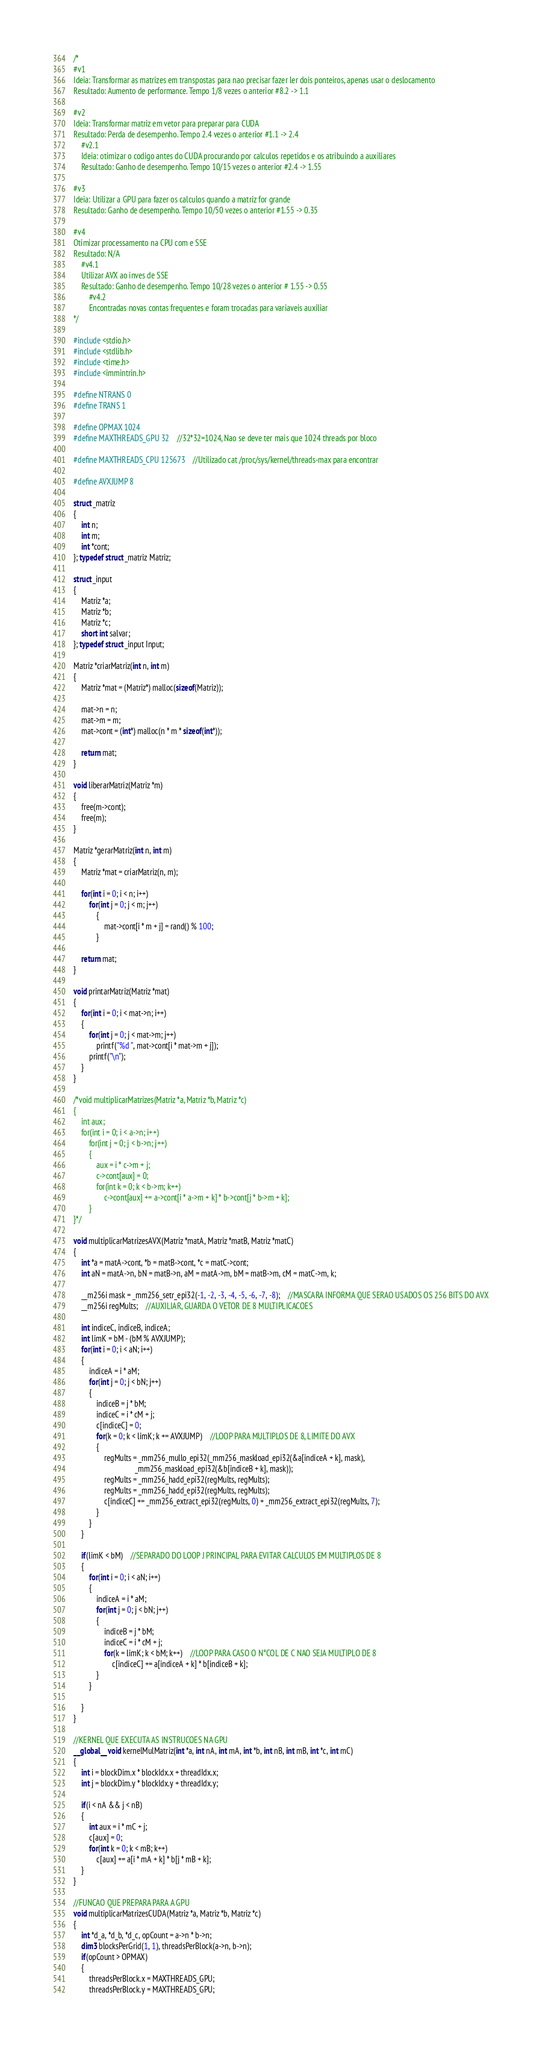<code> <loc_0><loc_0><loc_500><loc_500><_Cuda_>/*
#v1
Ideia: Transformar as matrizes em transpostas para nao precisar fazer ler dois ponteiros, apenas usar o deslocamento
Resultado: Aumento de performance. Tempo 1/8 vezes o anterior #8.2 -> 1.1

#v2
Ideia: Transformar matriz em vetor para preparar para CUDA
Resultado: Perda de desempenho. Tempo 2.4 vezes o anterior #1.1 -> 2.4
	#v2.1
	Ideia: otimizar o codigo antes do CUDA procurando por calculos repetidos e os atribuindo a auxiliares
	Resultado: Ganho de desempenho. Tempo 10/15 vezes o anterior #2.4 -> 1.55

#v3
Ideia: Utilizar a GPU para fazer os calculos quando a matriz for grande
Resultado: Ganho de desempenho. Tempo 10/50 vezes o anterior #1.55 -> 0.35

#v4
Otimizar processamento na CPU com e SSE
Resultado: N/A
	#v4.1
	Utilizar AVX ao inves de SSE
	Resultado: Ganho de desempenho. Tempo 10/28 vezes o anterior # 1.55 -> 0.55
		#v4.2
		Encontradas novas contas frequentes e foram trocadas para variaveis auxiliar
*/

#include <stdio.h>
#include <stdlib.h>
#include <time.h>
#include <immintrin.h>

#define NTRANS 0
#define TRANS 1

#define OPMAX 1024
#define MAXTHREADS_GPU 32	//32*32=1024, Nao se deve ter mais que 1024 threads por bloco

#define MAXTHREADS_CPU 125673	//Utilizado cat /proc/sys/kernel/threads-max para encontrar

#define AVXJUMP 8

struct _matriz
{
	int n;
	int m;
	int *cont;
}; typedef struct _matriz Matriz;

struct _input
{
	Matriz *a;
	Matriz *b;
	Matriz *c;
	short int salvar;
}; typedef struct _input Input;

Matriz *criarMatriz(int n, int m)
{
	Matriz *mat = (Matriz*) malloc(sizeof(Matriz));

	mat->n = n;
	mat->m = m;
	mat->cont = (int*) malloc(n * m * sizeof(int*));

	return mat;
}

void liberarMatriz(Matriz *m)
{
	free(m->cont);
	free(m);
}

Matriz *gerarMatriz(int n, int m)
{
	Matriz *mat = criarMatriz(n, m);
	
	for(int i = 0; i < n; i++)
		for(int j = 0; j < m; j++)
			{
				mat->cont[i * m + j] = rand() % 100;
			}

	return mat;
}

void printarMatriz(Matriz *mat)
{
	for(int i = 0; i < mat->n; i++)
	{
		for(int j = 0; j < mat->m; j++)
			printf("%d ", mat->cont[i * mat->m + j]);
		printf("\n");
	}
}

/*void multiplicarMatrizes(Matriz *a, Matriz *b, Matriz *c)
{
	int aux;
	for(int i = 0; i < a->n; i++)
		for(int j = 0; j < b->n; j++)
		{
			aux = i * c->m + j;
			c->cont[aux] = 0;
			for(int k = 0; k < b->m; k++)
				c->cont[aux] += a->cont[i * a->m + k] * b->cont[j * b->m + k];
		}
}*/

void multiplicarMatrizesAVX(Matriz *matA, Matriz *matB, Matriz *matC)
{
	int *a = matA->cont, *b = matB->cont, *c = matC->cont;
	int aN = matA->n, bN = matB->n, aM = matA->m, bM = matB->m, cM = matC->m, k;

	__m256i mask = _mm256_setr_epi32(-1, -2, -3, -4, -5, -6, -7, -8);	//MASCARA INFORMA QUE SERAO USADOS OS 256 BITS DO AVX
	__m256i regMults;	//AUXILIAR, GUARDA O VETOR DE 8 MULTIPLICACOES

	int indiceC, indiceB, indiceA;
	int limK = bM - (bM % AVXJUMP);
	for(int i = 0; i < aN; i++)
	{
		indiceA = i * aM;
		for(int j = 0; j < bN; j++)
		{
			indiceB = j * bM;
			indiceC = i * cM + j;
			c[indiceC] = 0;
			for(k = 0; k < limK; k += AVXJUMP)	//LOOP PARA MULTIPLOS DE 8, LIMITE DO AVX
			{
				regMults = _mm256_mullo_epi32(_mm256_maskload_epi32(&a[indiceA + k], mask),
								_mm256_maskload_epi32(&b[indiceB + k], mask));
				regMults = _mm256_hadd_epi32(regMults, regMults);
				regMults = _mm256_hadd_epi32(regMults, regMults);
				c[indiceC] += _mm256_extract_epi32(regMults, 0) + _mm256_extract_epi32(regMults, 7);
			}
		}
	}

	if(limK < bM)	//SEPARADO DO LOOP J PRINCIPAL PARA EVITAR CALCULOS EM MULTIPLOS DE 8
	{
		for(int i = 0; i < aN; i++)
		{
			indiceA = i * aM;
			for(int j = 0; j < bN; j++)
			{
				indiceB = j * bM;
				indiceC = i * cM + j;
				for(k = limK; k < bM; k++)	//LOOP PARA CASO O N°COL DE C NAO SEJA MULTIPLO DE 8
					c[indiceC] += a[indiceA + k] * b[indiceB + k];
			}
		}

	}
}

//KERNEL QUE EXECUTA AS INSTRUCOES NA GPU
__global__ void kernelMulMatriz(int *a, int nA, int mA, int *b, int nB, int mB, int *c, int mC)
{
	int i = blockDim.x * blockIdx.x + threadIdx.x;
	int j = blockDim.y * blockIdx.y + threadIdx.y;

	if(i < nA && j < nB)
	{
		int aux = i * mC + j;
		c[aux] = 0;
		for(int k = 0; k < mB; k++)
			c[aux] += a[i * mA + k] * b[j * mB + k];
	}
}

//FUNCAO QUE PREPARA PARA A GPU
void multiplicarMatrizesCUDA(Matriz *a, Matriz *b, Matriz *c)
{
	int *d_a, *d_b, *d_c, opCount = a->n * b->n;
	dim3 blocksPerGrid(1, 1), threadsPerBlock(a->n, b->n);
	if(opCount > OPMAX)
	{
		threadsPerBlock.x = MAXTHREADS_GPU;
		threadsPerBlock.y = MAXTHREADS_GPU;</code> 